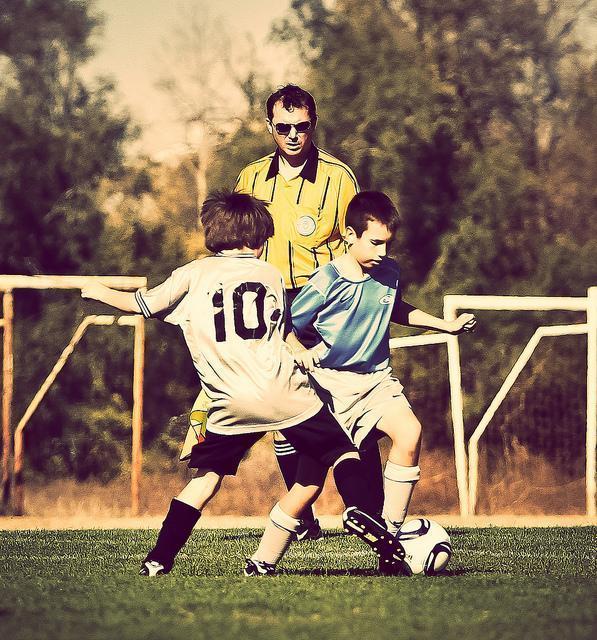How many people are there?
Give a very brief answer. 3. 